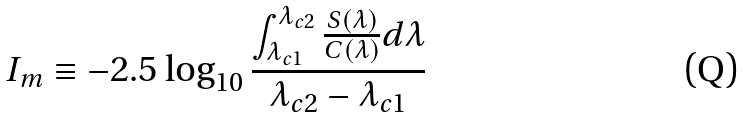Convert formula to latex. <formula><loc_0><loc_0><loc_500><loc_500>I _ { m } \equiv - 2 . 5 \log _ { 1 0 } \frac { \int _ { \lambda _ { c 1 } } ^ { \lambda _ { c 2 } } \frac { S ( \lambda ) } { C ( \lambda ) } d \lambda } { \lambda _ { c 2 } - \lambda _ { c 1 } }</formula> 